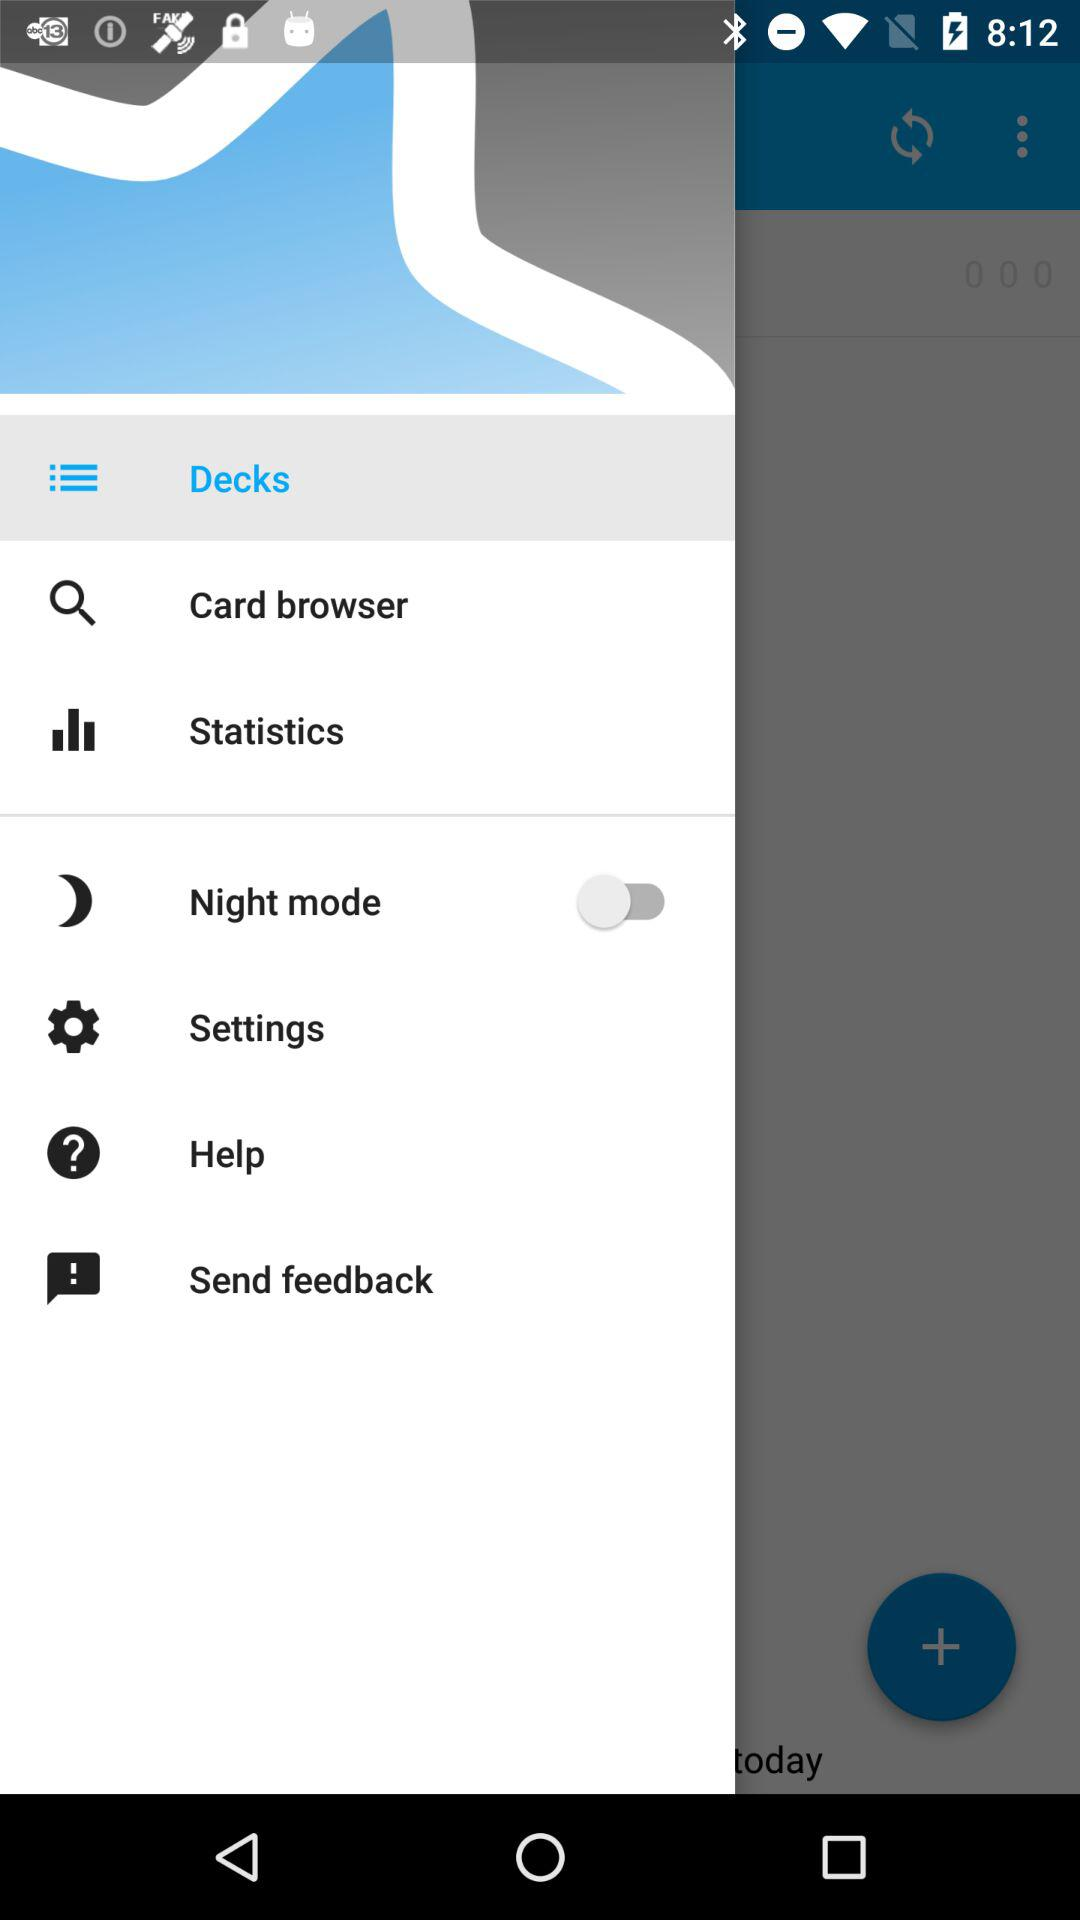What is the status of "Night mode"? The status is "off". 